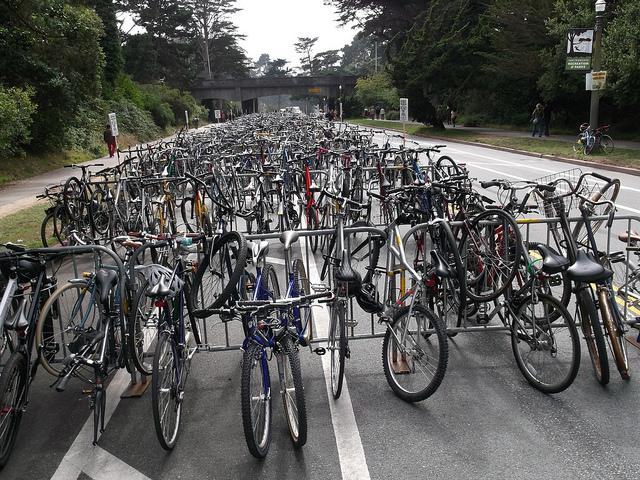What type of transportation is shown? Please explain your reasoning. road. The bikes are on a street. 